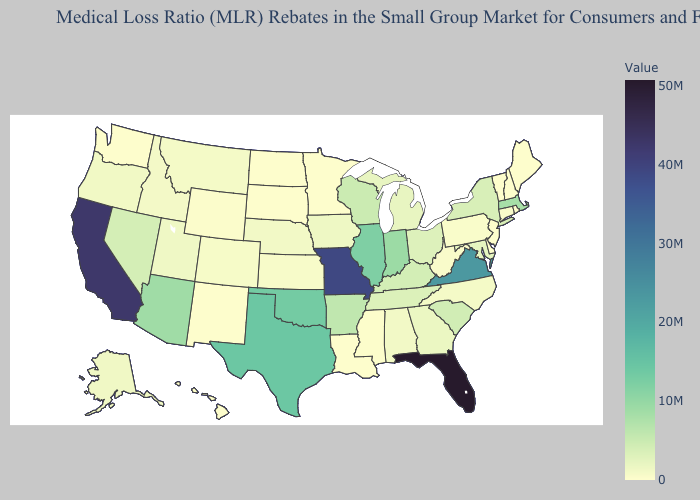Does Pennsylvania have the lowest value in the Northeast?
Quick response, please. No. Among the states that border Mississippi , does Louisiana have the lowest value?
Quick response, please. Yes. Does the map have missing data?
Concise answer only. No. Does New York have the highest value in the Northeast?
Keep it brief. No. Does Minnesota have the lowest value in the USA?
Give a very brief answer. Yes. Among the states that border Tennessee , which have the lowest value?
Give a very brief answer. Mississippi. Which states have the lowest value in the West?
Write a very short answer. Hawaii, New Mexico, Washington. 